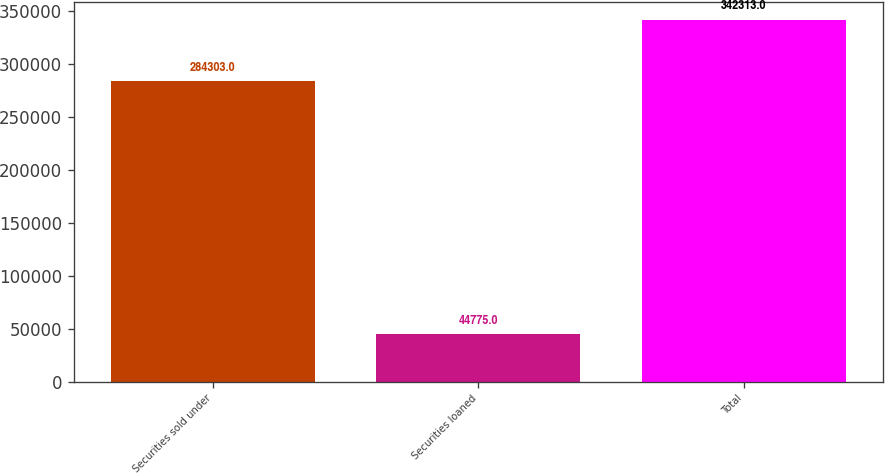Convert chart to OTSL. <chart><loc_0><loc_0><loc_500><loc_500><bar_chart><fcel>Securities sold under<fcel>Securities loaned<fcel>Total<nl><fcel>284303<fcel>44775<fcel>342313<nl></chart> 